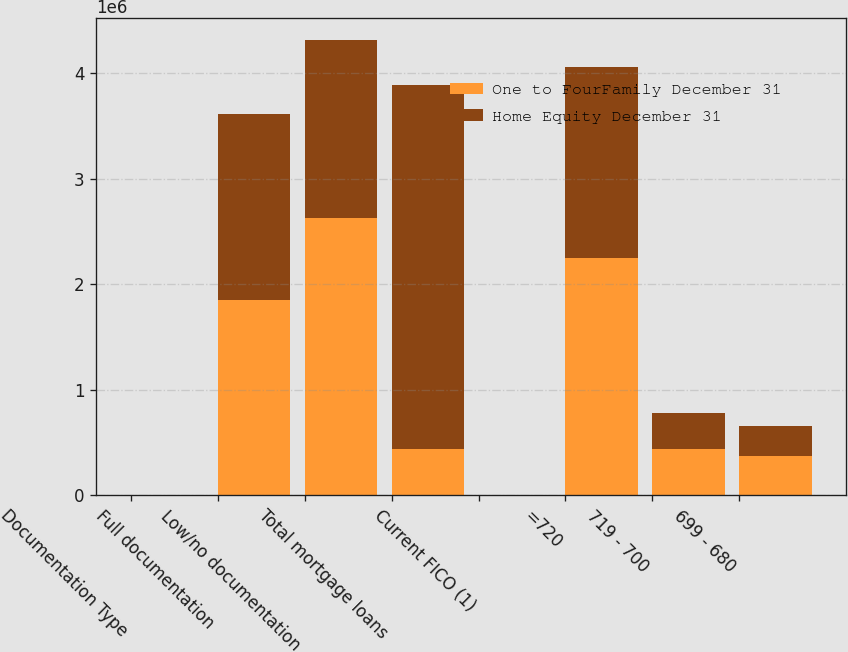Convert chart. <chart><loc_0><loc_0><loc_500><loc_500><stacked_bar_chart><ecel><fcel>Documentation Type<fcel>Full documentation<fcel>Low/no documentation<fcel>Total mortgage loans<fcel>Current FICO (1)<fcel>=720<fcel>719 - 700<fcel>699 - 680<nl><fcel>One to FourFamily December 31<fcel>2013<fcel>1.8468e+06<fcel>2.62799e+06<fcel>436316<fcel>2013<fcel>2.2515e+06<fcel>436316<fcel>366091<nl><fcel>Home Equity December 31<fcel>2013<fcel>1.76923e+06<fcel>1.68473e+06<fcel>3.45396e+06<fcel>2013<fcel>1.81078e+06<fcel>343321<fcel>293220<nl></chart> 